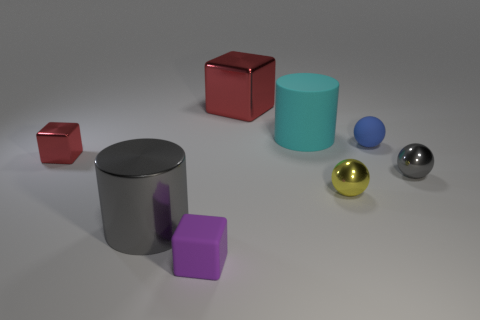Subtract all red blocks. How many were subtracted if there are1red blocks left? 1 Subtract all small yellow shiny balls. How many balls are left? 2 Subtract all purple cylinders. How many red cubes are left? 2 Add 2 big cyan things. How many objects exist? 10 Subtract all spheres. How many objects are left? 5 Subtract all tiny yellow spheres. Subtract all cyan objects. How many objects are left? 6 Add 4 tiny blue matte balls. How many tiny blue matte balls are left? 5 Add 7 tiny purple blocks. How many tiny purple blocks exist? 8 Subtract 1 blue spheres. How many objects are left? 7 Subtract all blue blocks. Subtract all green cylinders. How many blocks are left? 3 